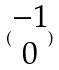Convert formula to latex. <formula><loc_0><loc_0><loc_500><loc_500>( \begin{matrix} - 1 \\ 0 \end{matrix} )</formula> 